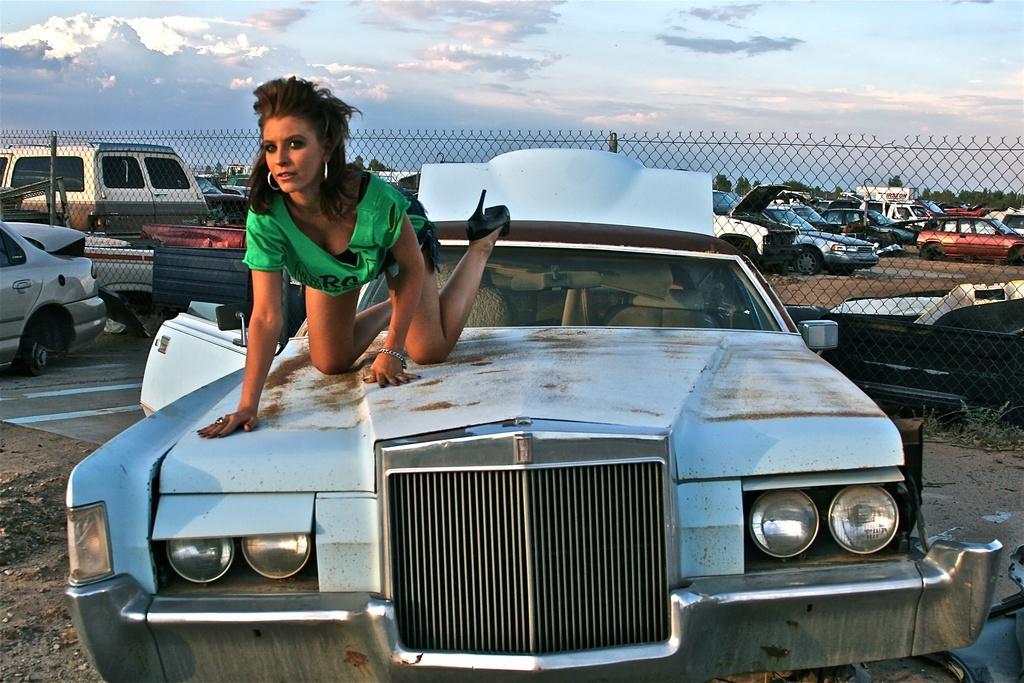In one or two sentences, can you explain what this image depicts? In the background we can see sky with clouds, trees, vehicles and mesh. We can see a woman wearing t-shirt is on the car. 